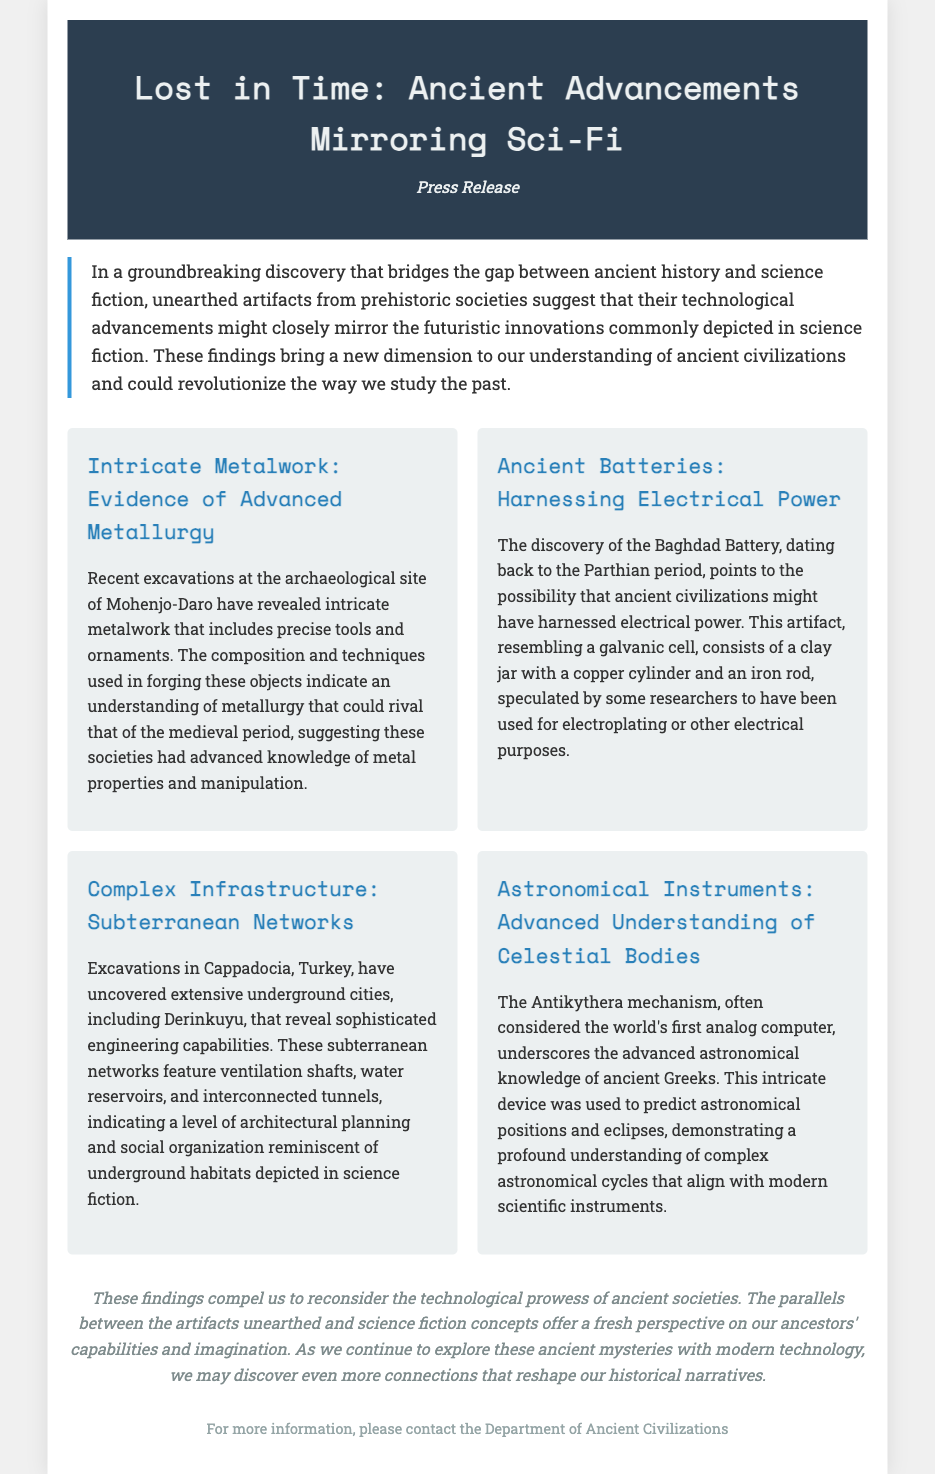What is the title of the press release? The title of the press release is prominently stated at the beginning of the document.
Answer: Lost in Time: Ancient Advancements Mirroring Sci-Fi Where was the intricate metalwork found? The location of the excavations revealing intricate metalwork is mentioned in the document.
Answer: Mohenjo-Daro What ancient artifact is associated with harnessing electrical power? The document identifies a specific artifact related to electrical power.
Answer: Baghdad Battery What is the name of the underground city mentioned in the document? The underground city uncovered in Turkey is specifically named in the findings.
Answer: Derinkuyu What is the purpose of the Antikythera mechanism? The document describes the main function of the Antikythera mechanism in the findings section.
Answer: Predict astronomical positions How do the findings challenge our understanding of ancient societies? The conclusion provides insight into how the findings affect perceptions of ancient technological prowess.
Answer: Reconsider technological prowess What type of discoveries does the press release discuss? The overall theme of the press release is indicated in the introduction.
Answer: Unearthed artifacts How does the document describe the engineering capabilities of ancient societies? The specific characteristics of these capabilities are elaborated in various sections of the document.
Answer: Sophisticated engineering capabilities 